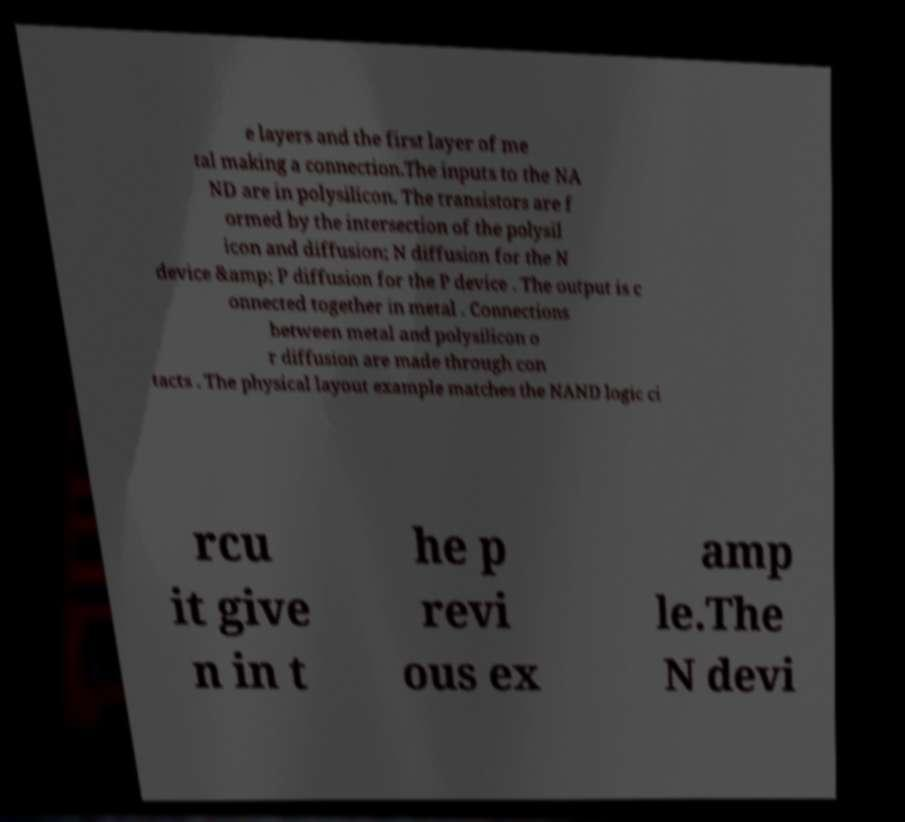Please identify and transcribe the text found in this image. e layers and the first layer of me tal making a connection.The inputs to the NA ND are in polysilicon. The transistors are f ormed by the intersection of the polysil icon and diffusion; N diffusion for the N device &amp; P diffusion for the P device . The output is c onnected together in metal . Connections between metal and polysilicon o r diffusion are made through con tacts . The physical layout example matches the NAND logic ci rcu it give n in t he p revi ous ex amp le.The N devi 